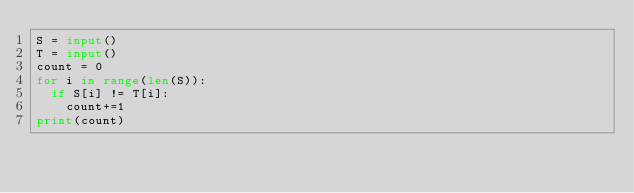<code> <loc_0><loc_0><loc_500><loc_500><_Python_>S = input()
T = input()
count = 0
for i in range(len(S)):
  if S[i] != T[i]:
    count+=1
print(count)</code> 